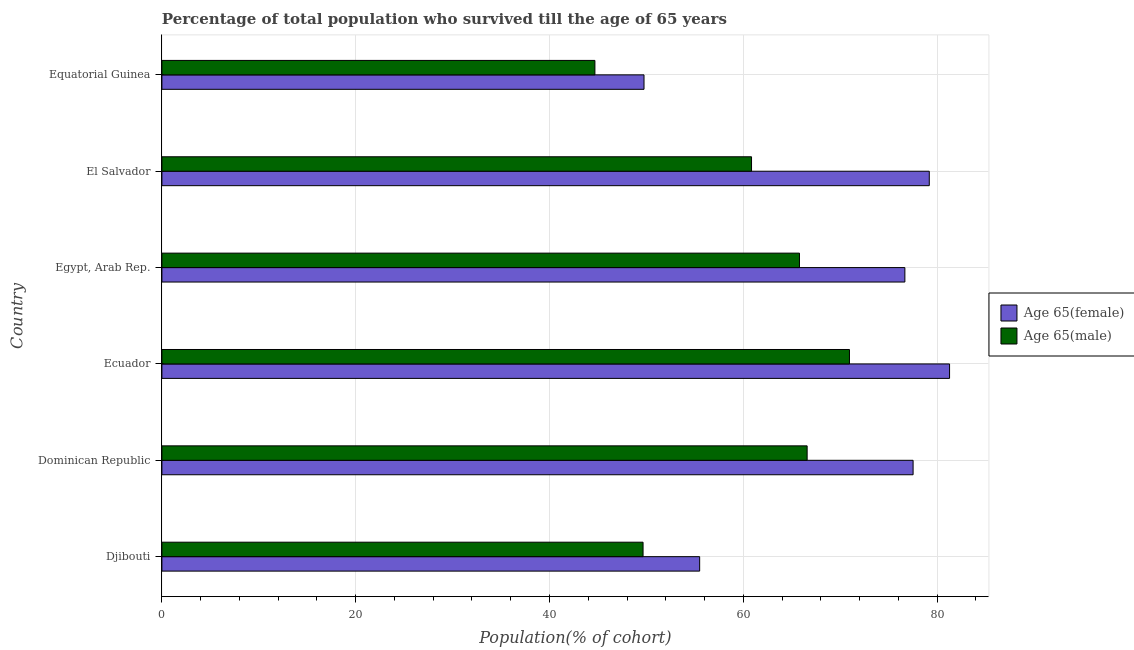Are the number of bars per tick equal to the number of legend labels?
Your answer should be very brief. Yes. Are the number of bars on each tick of the Y-axis equal?
Make the answer very short. Yes. How many bars are there on the 5th tick from the top?
Make the answer very short. 2. What is the label of the 6th group of bars from the top?
Your answer should be compact. Djibouti. What is the percentage of male population who survived till age of 65 in Egypt, Arab Rep.?
Keep it short and to the point. 65.8. Across all countries, what is the maximum percentage of female population who survived till age of 65?
Ensure brevity in your answer.  81.29. Across all countries, what is the minimum percentage of male population who survived till age of 65?
Provide a succinct answer. 44.69. In which country was the percentage of female population who survived till age of 65 maximum?
Offer a terse response. Ecuador. In which country was the percentage of female population who survived till age of 65 minimum?
Your answer should be very brief. Equatorial Guinea. What is the total percentage of male population who survived till age of 65 in the graph?
Ensure brevity in your answer.  358.55. What is the difference between the percentage of female population who survived till age of 65 in Dominican Republic and that in Egypt, Arab Rep.?
Provide a succinct answer. 0.85. What is the difference between the percentage of male population who survived till age of 65 in Equatorial Guinea and the percentage of female population who survived till age of 65 in Dominican Republic?
Your response must be concise. -32.84. What is the average percentage of male population who survived till age of 65 per country?
Keep it short and to the point. 59.76. What is the difference between the percentage of male population who survived till age of 65 and percentage of female population who survived till age of 65 in Djibouti?
Make the answer very short. -5.84. In how many countries, is the percentage of male population who survived till age of 65 greater than 44 %?
Give a very brief answer. 6. What is the ratio of the percentage of female population who survived till age of 65 in Djibouti to that in Ecuador?
Provide a succinct answer. 0.68. Is the difference between the percentage of male population who survived till age of 65 in Djibouti and Ecuador greater than the difference between the percentage of female population who survived till age of 65 in Djibouti and Ecuador?
Give a very brief answer. Yes. What is the difference between the highest and the second highest percentage of female population who survived till age of 65?
Offer a very short reply. 2.09. What is the difference between the highest and the lowest percentage of male population who survived till age of 65?
Offer a very short reply. 26.27. Is the sum of the percentage of female population who survived till age of 65 in Djibouti and El Salvador greater than the maximum percentage of male population who survived till age of 65 across all countries?
Your answer should be compact. Yes. What does the 1st bar from the top in El Salvador represents?
Provide a short and direct response. Age 65(male). What does the 2nd bar from the bottom in El Salvador represents?
Your answer should be very brief. Age 65(male). Are all the bars in the graph horizontal?
Ensure brevity in your answer.  Yes. How many countries are there in the graph?
Your answer should be compact. 6. Are the values on the major ticks of X-axis written in scientific E-notation?
Ensure brevity in your answer.  No. Does the graph contain any zero values?
Your answer should be very brief. No. Does the graph contain grids?
Ensure brevity in your answer.  Yes. Where does the legend appear in the graph?
Your answer should be compact. Center right. What is the title of the graph?
Offer a very short reply. Percentage of total population who survived till the age of 65 years. Does "Commercial service imports" appear as one of the legend labels in the graph?
Your response must be concise. No. What is the label or title of the X-axis?
Keep it short and to the point. Population(% of cohort). What is the Population(% of cohort) in Age 65(female) in Djibouti?
Ensure brevity in your answer.  55.5. What is the Population(% of cohort) in Age 65(male) in Djibouti?
Provide a succinct answer. 49.66. What is the Population(% of cohort) of Age 65(female) in Dominican Republic?
Offer a very short reply. 77.53. What is the Population(% of cohort) of Age 65(male) in Dominican Republic?
Your answer should be compact. 66.59. What is the Population(% of cohort) in Age 65(female) in Ecuador?
Make the answer very short. 81.29. What is the Population(% of cohort) of Age 65(male) in Ecuador?
Offer a very short reply. 70.96. What is the Population(% of cohort) in Age 65(female) in Egypt, Arab Rep.?
Your answer should be very brief. 76.68. What is the Population(% of cohort) of Age 65(male) in Egypt, Arab Rep.?
Provide a succinct answer. 65.8. What is the Population(% of cohort) in Age 65(female) in El Salvador?
Provide a short and direct response. 79.2. What is the Population(% of cohort) in Age 65(male) in El Salvador?
Provide a short and direct response. 60.85. What is the Population(% of cohort) of Age 65(female) in Equatorial Guinea?
Offer a very short reply. 49.76. What is the Population(% of cohort) in Age 65(male) in Equatorial Guinea?
Provide a succinct answer. 44.69. Across all countries, what is the maximum Population(% of cohort) of Age 65(female)?
Give a very brief answer. 81.29. Across all countries, what is the maximum Population(% of cohort) of Age 65(male)?
Your answer should be very brief. 70.96. Across all countries, what is the minimum Population(% of cohort) of Age 65(female)?
Offer a terse response. 49.76. Across all countries, what is the minimum Population(% of cohort) of Age 65(male)?
Give a very brief answer. 44.69. What is the total Population(% of cohort) of Age 65(female) in the graph?
Provide a succinct answer. 419.94. What is the total Population(% of cohort) of Age 65(male) in the graph?
Provide a succinct answer. 358.55. What is the difference between the Population(% of cohort) of Age 65(female) in Djibouti and that in Dominican Republic?
Give a very brief answer. -22.03. What is the difference between the Population(% of cohort) of Age 65(male) in Djibouti and that in Dominican Republic?
Offer a very short reply. -16.93. What is the difference between the Population(% of cohort) of Age 65(female) in Djibouti and that in Ecuador?
Make the answer very short. -25.79. What is the difference between the Population(% of cohort) of Age 65(male) in Djibouti and that in Ecuador?
Ensure brevity in your answer.  -21.3. What is the difference between the Population(% of cohort) in Age 65(female) in Djibouti and that in Egypt, Arab Rep.?
Your response must be concise. -21.18. What is the difference between the Population(% of cohort) of Age 65(male) in Djibouti and that in Egypt, Arab Rep.?
Give a very brief answer. -16.14. What is the difference between the Population(% of cohort) of Age 65(female) in Djibouti and that in El Salvador?
Offer a terse response. -23.7. What is the difference between the Population(% of cohort) in Age 65(male) in Djibouti and that in El Salvador?
Your response must be concise. -11.2. What is the difference between the Population(% of cohort) of Age 65(female) in Djibouti and that in Equatorial Guinea?
Provide a succinct answer. 5.74. What is the difference between the Population(% of cohort) of Age 65(male) in Djibouti and that in Equatorial Guinea?
Ensure brevity in your answer.  4.97. What is the difference between the Population(% of cohort) in Age 65(female) in Dominican Republic and that in Ecuador?
Ensure brevity in your answer.  -3.76. What is the difference between the Population(% of cohort) of Age 65(male) in Dominican Republic and that in Ecuador?
Your answer should be compact. -4.37. What is the difference between the Population(% of cohort) in Age 65(female) in Dominican Republic and that in Egypt, Arab Rep.?
Make the answer very short. 0.85. What is the difference between the Population(% of cohort) of Age 65(male) in Dominican Republic and that in Egypt, Arab Rep.?
Give a very brief answer. 0.79. What is the difference between the Population(% of cohort) of Age 65(female) in Dominican Republic and that in El Salvador?
Give a very brief answer. -1.67. What is the difference between the Population(% of cohort) of Age 65(male) in Dominican Republic and that in El Salvador?
Your response must be concise. 5.74. What is the difference between the Population(% of cohort) in Age 65(female) in Dominican Republic and that in Equatorial Guinea?
Your answer should be very brief. 27.77. What is the difference between the Population(% of cohort) in Age 65(male) in Dominican Republic and that in Equatorial Guinea?
Offer a very short reply. 21.9. What is the difference between the Population(% of cohort) of Age 65(female) in Ecuador and that in Egypt, Arab Rep.?
Your response must be concise. 4.61. What is the difference between the Population(% of cohort) of Age 65(male) in Ecuador and that in Egypt, Arab Rep.?
Offer a terse response. 5.16. What is the difference between the Population(% of cohort) of Age 65(female) in Ecuador and that in El Salvador?
Your answer should be compact. 2.09. What is the difference between the Population(% of cohort) of Age 65(male) in Ecuador and that in El Salvador?
Provide a short and direct response. 10.11. What is the difference between the Population(% of cohort) in Age 65(female) in Ecuador and that in Equatorial Guinea?
Provide a short and direct response. 31.53. What is the difference between the Population(% of cohort) of Age 65(male) in Ecuador and that in Equatorial Guinea?
Keep it short and to the point. 26.27. What is the difference between the Population(% of cohort) of Age 65(female) in Egypt, Arab Rep. and that in El Salvador?
Provide a succinct answer. -2.52. What is the difference between the Population(% of cohort) of Age 65(male) in Egypt, Arab Rep. and that in El Salvador?
Give a very brief answer. 4.95. What is the difference between the Population(% of cohort) in Age 65(female) in Egypt, Arab Rep. and that in Equatorial Guinea?
Your answer should be compact. 26.92. What is the difference between the Population(% of cohort) of Age 65(male) in Egypt, Arab Rep. and that in Equatorial Guinea?
Keep it short and to the point. 21.11. What is the difference between the Population(% of cohort) in Age 65(female) in El Salvador and that in Equatorial Guinea?
Keep it short and to the point. 29.44. What is the difference between the Population(% of cohort) in Age 65(male) in El Salvador and that in Equatorial Guinea?
Provide a succinct answer. 16.16. What is the difference between the Population(% of cohort) in Age 65(female) in Djibouti and the Population(% of cohort) in Age 65(male) in Dominican Republic?
Your answer should be compact. -11.09. What is the difference between the Population(% of cohort) in Age 65(female) in Djibouti and the Population(% of cohort) in Age 65(male) in Ecuador?
Keep it short and to the point. -15.46. What is the difference between the Population(% of cohort) of Age 65(female) in Djibouti and the Population(% of cohort) of Age 65(male) in Egypt, Arab Rep.?
Provide a succinct answer. -10.3. What is the difference between the Population(% of cohort) in Age 65(female) in Djibouti and the Population(% of cohort) in Age 65(male) in El Salvador?
Provide a succinct answer. -5.35. What is the difference between the Population(% of cohort) of Age 65(female) in Djibouti and the Population(% of cohort) of Age 65(male) in Equatorial Guinea?
Your response must be concise. 10.81. What is the difference between the Population(% of cohort) of Age 65(female) in Dominican Republic and the Population(% of cohort) of Age 65(male) in Ecuador?
Your response must be concise. 6.57. What is the difference between the Population(% of cohort) of Age 65(female) in Dominican Republic and the Population(% of cohort) of Age 65(male) in Egypt, Arab Rep.?
Your response must be concise. 11.73. What is the difference between the Population(% of cohort) in Age 65(female) in Dominican Republic and the Population(% of cohort) in Age 65(male) in El Salvador?
Ensure brevity in your answer.  16.67. What is the difference between the Population(% of cohort) of Age 65(female) in Dominican Republic and the Population(% of cohort) of Age 65(male) in Equatorial Guinea?
Give a very brief answer. 32.84. What is the difference between the Population(% of cohort) in Age 65(female) in Ecuador and the Population(% of cohort) in Age 65(male) in Egypt, Arab Rep.?
Give a very brief answer. 15.49. What is the difference between the Population(% of cohort) of Age 65(female) in Ecuador and the Population(% of cohort) of Age 65(male) in El Salvador?
Provide a short and direct response. 20.44. What is the difference between the Population(% of cohort) in Age 65(female) in Ecuador and the Population(% of cohort) in Age 65(male) in Equatorial Guinea?
Provide a succinct answer. 36.6. What is the difference between the Population(% of cohort) in Age 65(female) in Egypt, Arab Rep. and the Population(% of cohort) in Age 65(male) in El Salvador?
Offer a very short reply. 15.82. What is the difference between the Population(% of cohort) of Age 65(female) in Egypt, Arab Rep. and the Population(% of cohort) of Age 65(male) in Equatorial Guinea?
Your answer should be compact. 31.99. What is the difference between the Population(% of cohort) in Age 65(female) in El Salvador and the Population(% of cohort) in Age 65(male) in Equatorial Guinea?
Your response must be concise. 34.51. What is the average Population(% of cohort) of Age 65(female) per country?
Give a very brief answer. 69.99. What is the average Population(% of cohort) of Age 65(male) per country?
Keep it short and to the point. 59.76. What is the difference between the Population(% of cohort) in Age 65(female) and Population(% of cohort) in Age 65(male) in Djibouti?
Offer a very short reply. 5.84. What is the difference between the Population(% of cohort) in Age 65(female) and Population(% of cohort) in Age 65(male) in Dominican Republic?
Your response must be concise. 10.94. What is the difference between the Population(% of cohort) of Age 65(female) and Population(% of cohort) of Age 65(male) in Ecuador?
Provide a short and direct response. 10.33. What is the difference between the Population(% of cohort) of Age 65(female) and Population(% of cohort) of Age 65(male) in Egypt, Arab Rep.?
Ensure brevity in your answer.  10.88. What is the difference between the Population(% of cohort) in Age 65(female) and Population(% of cohort) in Age 65(male) in El Salvador?
Give a very brief answer. 18.34. What is the difference between the Population(% of cohort) in Age 65(female) and Population(% of cohort) in Age 65(male) in Equatorial Guinea?
Keep it short and to the point. 5.07. What is the ratio of the Population(% of cohort) of Age 65(female) in Djibouti to that in Dominican Republic?
Ensure brevity in your answer.  0.72. What is the ratio of the Population(% of cohort) of Age 65(male) in Djibouti to that in Dominican Republic?
Give a very brief answer. 0.75. What is the ratio of the Population(% of cohort) of Age 65(female) in Djibouti to that in Ecuador?
Offer a terse response. 0.68. What is the ratio of the Population(% of cohort) of Age 65(male) in Djibouti to that in Ecuador?
Give a very brief answer. 0.7. What is the ratio of the Population(% of cohort) in Age 65(female) in Djibouti to that in Egypt, Arab Rep.?
Offer a terse response. 0.72. What is the ratio of the Population(% of cohort) of Age 65(male) in Djibouti to that in Egypt, Arab Rep.?
Provide a short and direct response. 0.75. What is the ratio of the Population(% of cohort) of Age 65(female) in Djibouti to that in El Salvador?
Your answer should be compact. 0.7. What is the ratio of the Population(% of cohort) of Age 65(male) in Djibouti to that in El Salvador?
Offer a very short reply. 0.82. What is the ratio of the Population(% of cohort) of Age 65(female) in Djibouti to that in Equatorial Guinea?
Your response must be concise. 1.12. What is the ratio of the Population(% of cohort) of Age 65(male) in Djibouti to that in Equatorial Guinea?
Give a very brief answer. 1.11. What is the ratio of the Population(% of cohort) in Age 65(female) in Dominican Republic to that in Ecuador?
Keep it short and to the point. 0.95. What is the ratio of the Population(% of cohort) in Age 65(male) in Dominican Republic to that in Ecuador?
Keep it short and to the point. 0.94. What is the ratio of the Population(% of cohort) in Age 65(female) in Dominican Republic to that in Egypt, Arab Rep.?
Your answer should be very brief. 1.01. What is the ratio of the Population(% of cohort) of Age 65(male) in Dominican Republic to that in Egypt, Arab Rep.?
Ensure brevity in your answer.  1.01. What is the ratio of the Population(% of cohort) of Age 65(female) in Dominican Republic to that in El Salvador?
Offer a terse response. 0.98. What is the ratio of the Population(% of cohort) of Age 65(male) in Dominican Republic to that in El Salvador?
Keep it short and to the point. 1.09. What is the ratio of the Population(% of cohort) in Age 65(female) in Dominican Republic to that in Equatorial Guinea?
Offer a terse response. 1.56. What is the ratio of the Population(% of cohort) of Age 65(male) in Dominican Republic to that in Equatorial Guinea?
Your answer should be very brief. 1.49. What is the ratio of the Population(% of cohort) in Age 65(female) in Ecuador to that in Egypt, Arab Rep.?
Your response must be concise. 1.06. What is the ratio of the Population(% of cohort) of Age 65(male) in Ecuador to that in Egypt, Arab Rep.?
Your answer should be very brief. 1.08. What is the ratio of the Population(% of cohort) in Age 65(female) in Ecuador to that in El Salvador?
Provide a short and direct response. 1.03. What is the ratio of the Population(% of cohort) in Age 65(male) in Ecuador to that in El Salvador?
Ensure brevity in your answer.  1.17. What is the ratio of the Population(% of cohort) of Age 65(female) in Ecuador to that in Equatorial Guinea?
Provide a short and direct response. 1.63. What is the ratio of the Population(% of cohort) of Age 65(male) in Ecuador to that in Equatorial Guinea?
Keep it short and to the point. 1.59. What is the ratio of the Population(% of cohort) in Age 65(female) in Egypt, Arab Rep. to that in El Salvador?
Provide a short and direct response. 0.97. What is the ratio of the Population(% of cohort) of Age 65(male) in Egypt, Arab Rep. to that in El Salvador?
Ensure brevity in your answer.  1.08. What is the ratio of the Population(% of cohort) in Age 65(female) in Egypt, Arab Rep. to that in Equatorial Guinea?
Provide a succinct answer. 1.54. What is the ratio of the Population(% of cohort) of Age 65(male) in Egypt, Arab Rep. to that in Equatorial Guinea?
Offer a terse response. 1.47. What is the ratio of the Population(% of cohort) in Age 65(female) in El Salvador to that in Equatorial Guinea?
Keep it short and to the point. 1.59. What is the ratio of the Population(% of cohort) of Age 65(male) in El Salvador to that in Equatorial Guinea?
Your answer should be very brief. 1.36. What is the difference between the highest and the second highest Population(% of cohort) in Age 65(female)?
Provide a succinct answer. 2.09. What is the difference between the highest and the second highest Population(% of cohort) in Age 65(male)?
Ensure brevity in your answer.  4.37. What is the difference between the highest and the lowest Population(% of cohort) of Age 65(female)?
Provide a succinct answer. 31.53. What is the difference between the highest and the lowest Population(% of cohort) in Age 65(male)?
Keep it short and to the point. 26.27. 